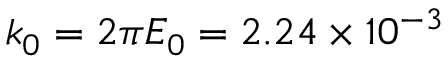Convert formula to latex. <formula><loc_0><loc_0><loc_500><loc_500>k _ { 0 } = 2 \pi E _ { 0 } = 2 . 2 4 \times 1 0 ^ { - 3 }</formula> 